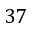Convert formula to latex. <formula><loc_0><loc_0><loc_500><loc_500>3 7</formula> 